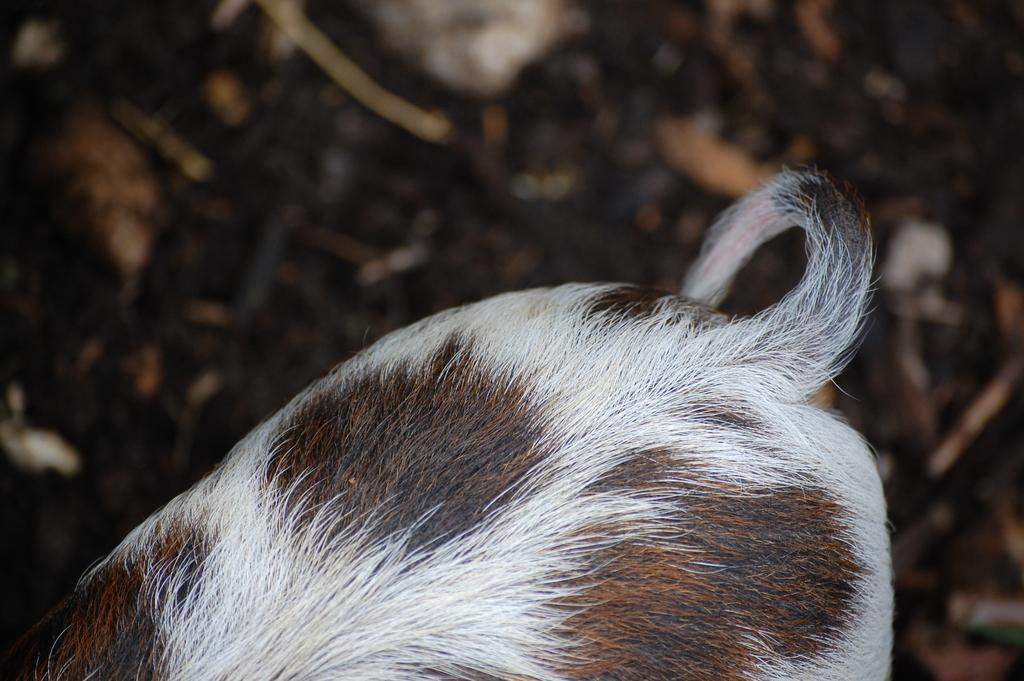What part of an animal can be seen in the image? The tail of an animal is visible in the image. What type of dinosaur can be seen in the image? There is no dinosaur present in the image; only the tail of an animal is visible. What does the mountain smell like in the image? There is no mountain present in the image, so it is not possible to determine what it might smell like. 